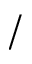Convert formula to latex. <formula><loc_0><loc_0><loc_500><loc_500>/</formula> 